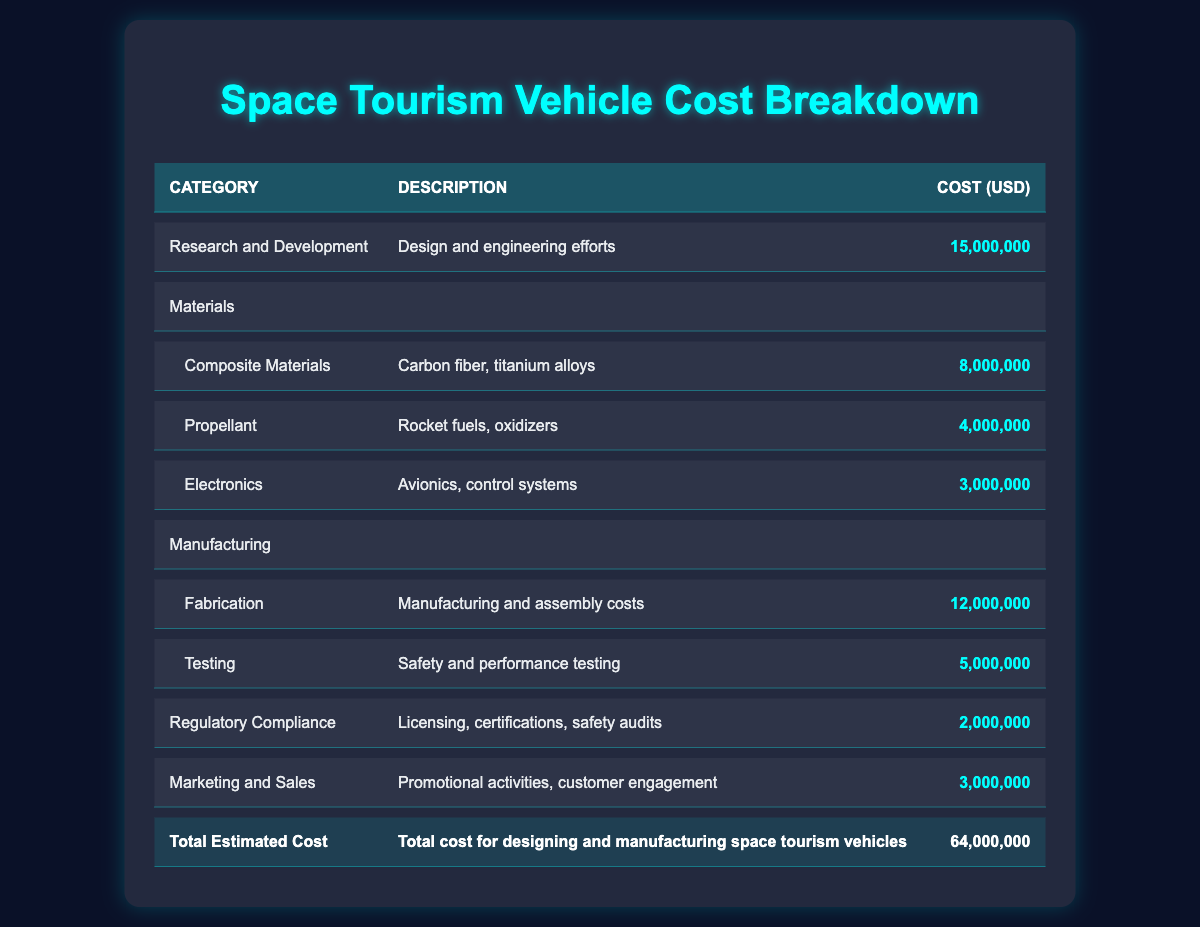What is the total estimated cost for designing and manufacturing space tourism vehicles? The total estimated cost is located in the last row of the table, indicated as "Total Estimated Cost," which shows the value of 64,000,000 USD.
Answer: 64,000,000 USD What is the cost of materials used in space tourism vehicles? The cost of materials is totalled by adding the individual costs of Composite Materials (8,000,000 USD), Propellant (4,000,000 USD), and Electronics (3,000,000 USD), which sums up to 8,000,000 + 4,000,000 + 3,000,000 = 15,000,000 USD.
Answer: 15,000,000 USD Is the cost of research and development higher than the combined cost of marketing and sales and regulatory compliance? The cost of research and development is 15,000,000 USD, while the combined cost of marketing and sales (3,000,000 USD) and regulatory compliance (2,000,000 USD) is 3,000,000 + 2,000,000 = 5,000,000 USD. 15,000,000 USD is greater than 5,000,000 USD, so the statement is true.
Answer: Yes What is the cost difference between manufacturing and research and development? The cost of manufacturing is the sum of Fabrication (12,000,000 USD) and Testing (5,000,000 USD), which totals to 12,000,000 + 5,000,000 = 17,000,000 USD. The difference is calculated by subtracting the research and development cost (15,000,000 USD) from the total manufacturing cost (17,000,000 USD), leading to 17,000,000 USD - 15,000,000 USD = 2,000,000 USD.
Answer: 2,000,000 USD What percentage of the total cost is allocated to regulatory compliance? The regulatory compliance cost is 2,000,000 USD, and to find the percentage of total cost, we divide it by the total estimated cost (64,000,000 USD) and then multiply by 100. Therefore, (2,000,000 / 64,000,000) * 100 = 3.125%.
Answer: 3.125% 